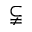<formula> <loc_0><loc_0><loc_500><loc_500>\subsetneqq</formula> 